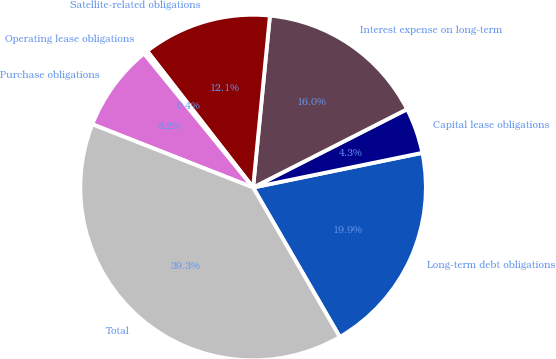Convert chart. <chart><loc_0><loc_0><loc_500><loc_500><pie_chart><fcel>Long-term debt obligations<fcel>Capital lease obligations<fcel>Interest expense on long-term<fcel>Satellite-related obligations<fcel>Operating lease obligations<fcel>Purchase obligations<fcel>Total<nl><fcel>19.85%<fcel>4.27%<fcel>15.96%<fcel>12.06%<fcel>0.37%<fcel>8.16%<fcel>39.33%<nl></chart> 